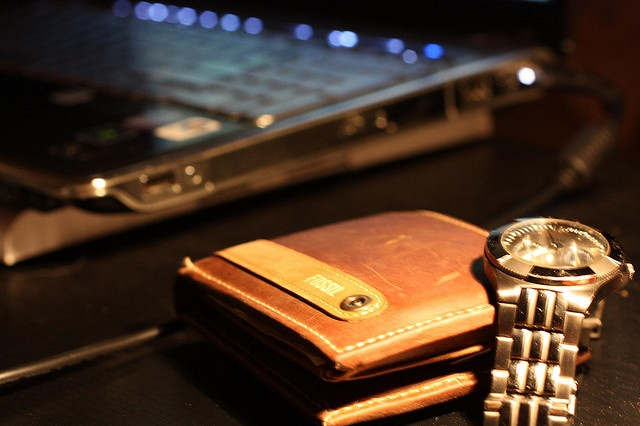Describe the objects in this image and their specific colors. I can see laptop in black, gray, and maroon tones and clock in black, maroon, tan, and khaki tones in this image. 